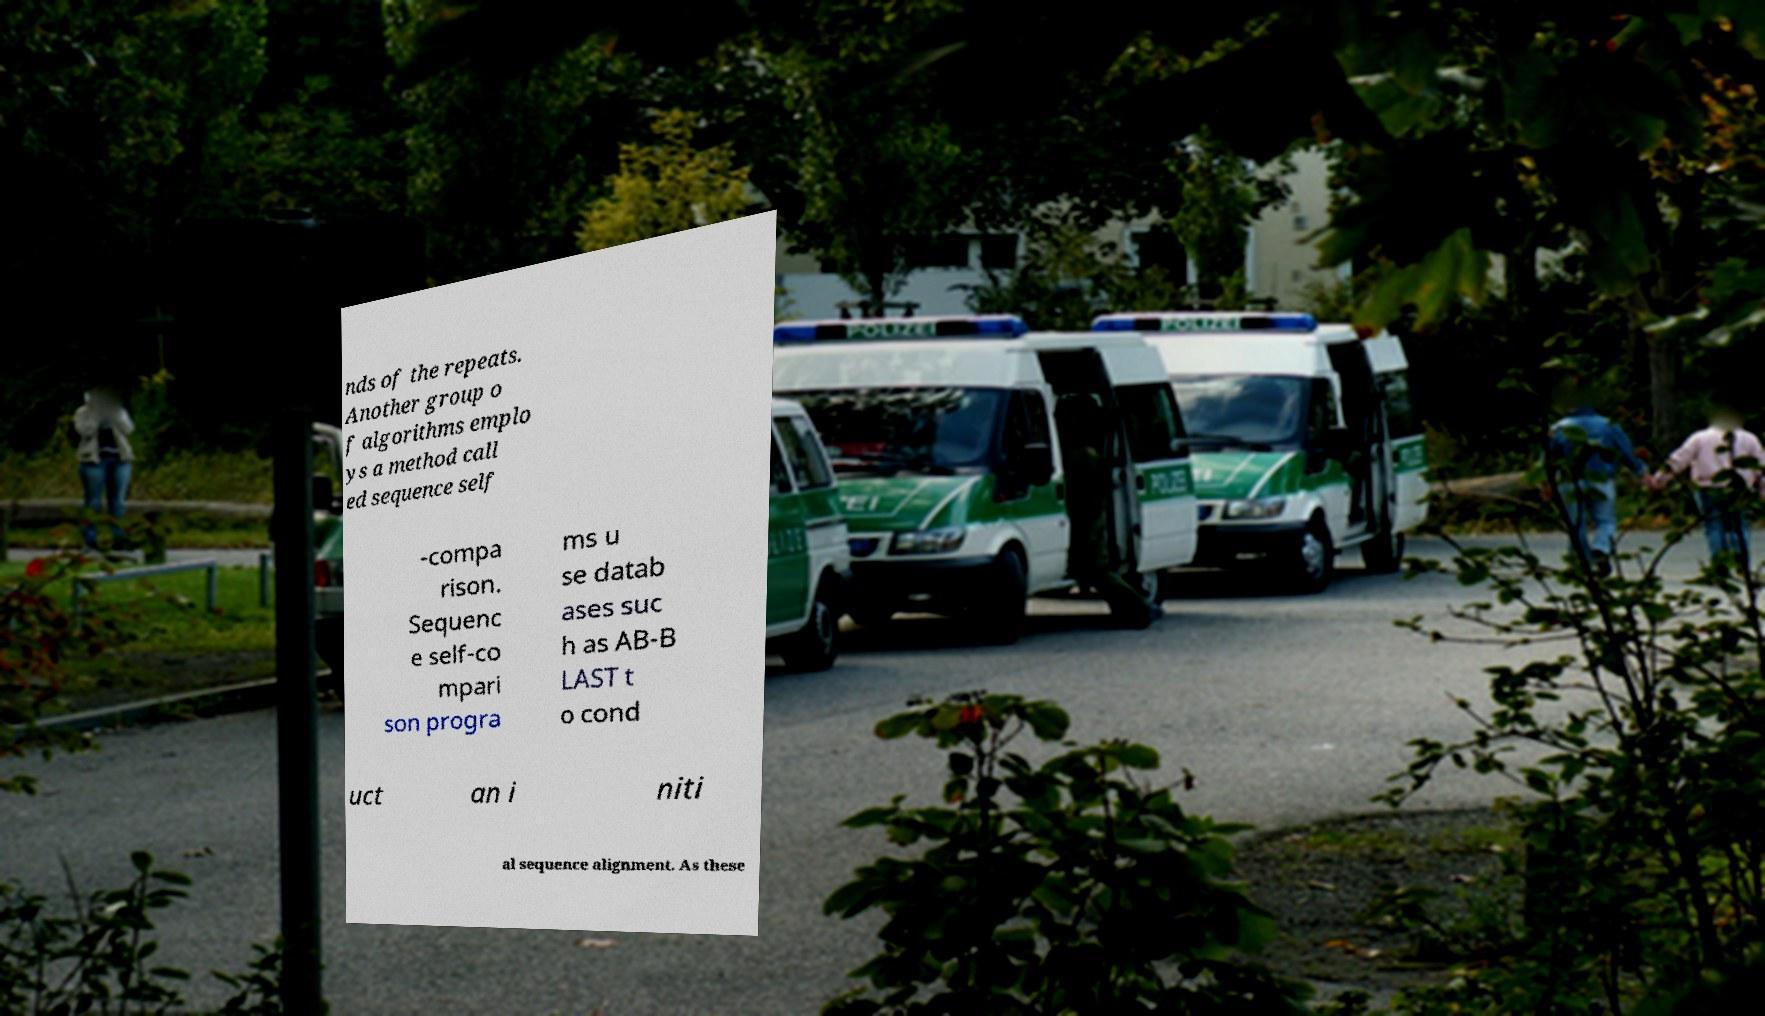Can you accurately transcribe the text from the provided image for me? nds of the repeats. Another group o f algorithms emplo ys a method call ed sequence self -compa rison. Sequenc e self-co mpari son progra ms u se datab ases suc h as AB-B LAST t o cond uct an i niti al sequence alignment. As these 